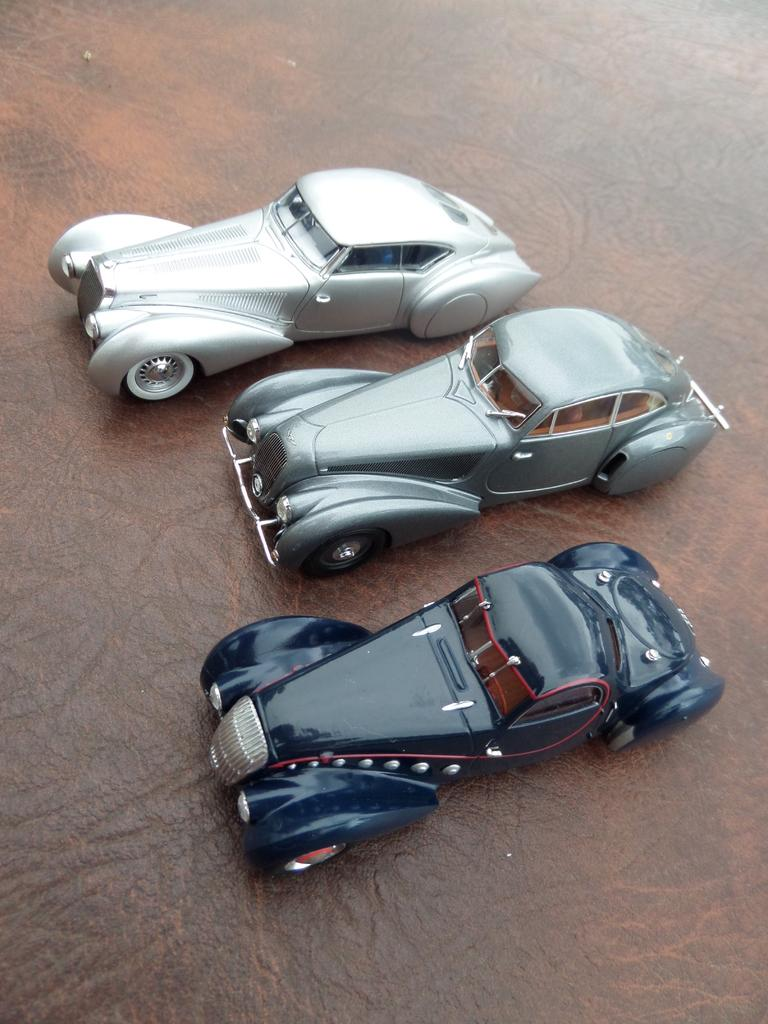What objects are in the middle of the image? There are three toy cars in the middle of the image. What type of surface is at the bottom of the image? There is a wooden surface at the bottom of the image. Can you see the queen playing baseball near the lake in the image? No, there is no queen, baseball, or lake present in the image. The image only features three toy cars and a wooden surface. 